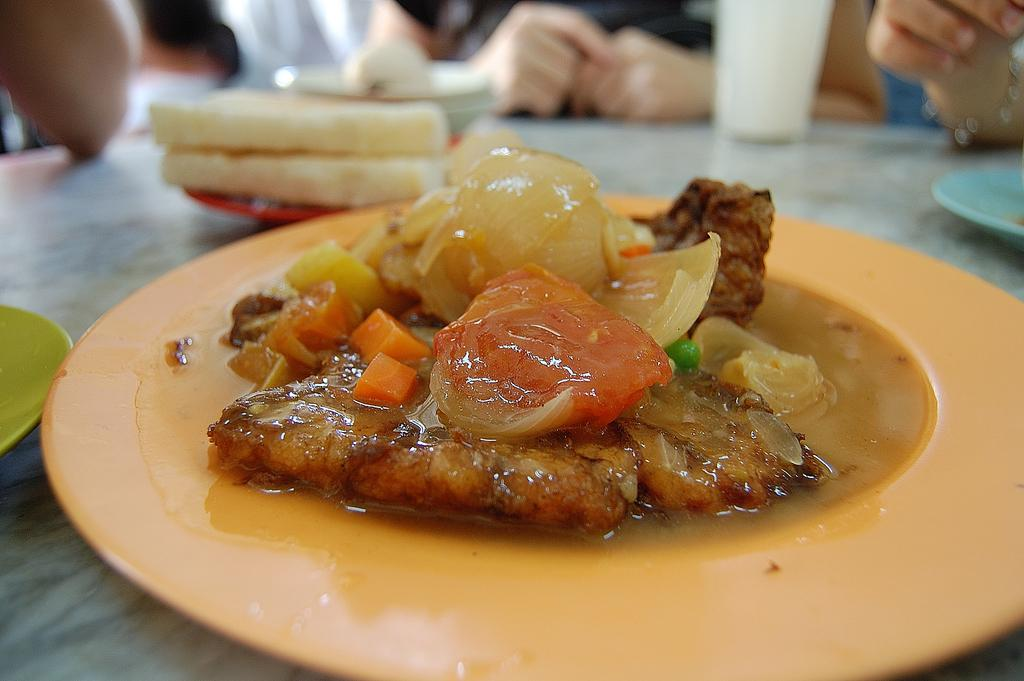What piece of furniture is present in the image? There is a table in the image. What objects are placed on the table? There are plates, glasses, and food items on the table. Can you describe the items on the table? The plates and glasses are used for serving and consuming food and beverages, while the food items are likely for consumption. Are there any people visible in the image? Yes, there are persons visible at the back of the image. What type of ghost can be seen interacting with the food items on the table? There is no ghost present in the image, and therefore no such interaction can be observed. Can you tell me how many basketballs are visible on the table? There are no basketballs present on the table; the image features plates, glasses, and food items. 